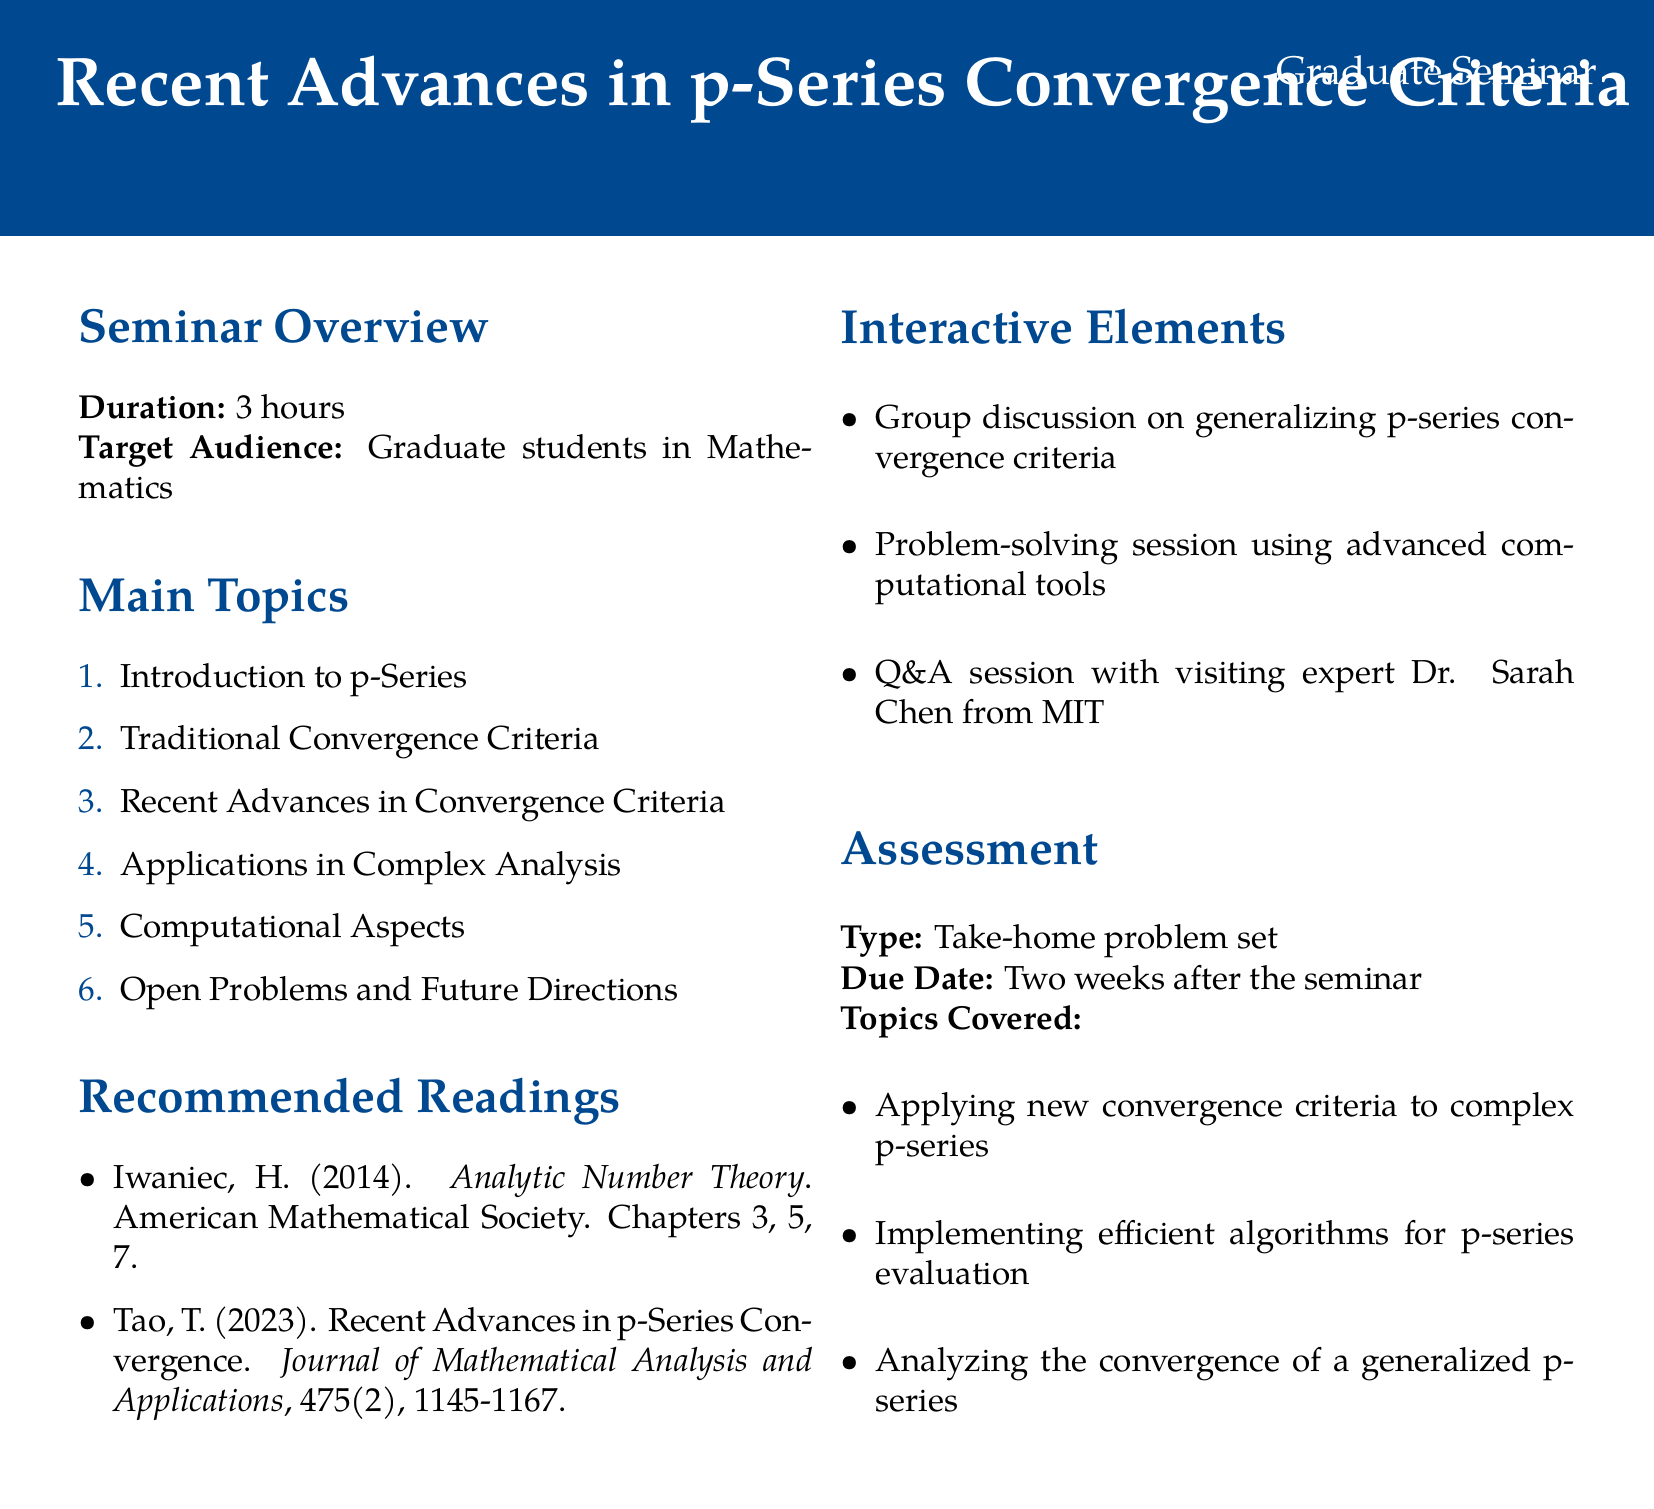What is the title of the seminar? The title of the seminar is specified at the beginning of the document.
Answer: Recent Advances in p-Series Convergence Criteria Who is the target audience? The document states the intended participants for the seminar.
Answer: Graduate students in Mathematics How long is the seminar scheduled to last? The seminar duration is explicitly mentioned in the document.
Answer: 3 hours Name one recent advance in convergence criteria mentioned. The document lists various recent advancements under the main topic section.
Answer: Generalizations of the integral test by Oleg Ivrii Which notable expert will be part of the Q&A session? The document names the visiting expert who will participate in the seminar.
Answer: Dr. Sarah Chen from MIT What type of assessment will be given after the seminar? The document specifies the format of the assessment to be completed after the seminar.
Answer: Take-home problem set When is the due date for the assessment? The document provides a specific timeframe for the assessment submission.
Answer: Two weeks after the seminar What is one application area mentioned for the p-series? The document lists different application areas under one main topic.
Answer: Complex Analysis 